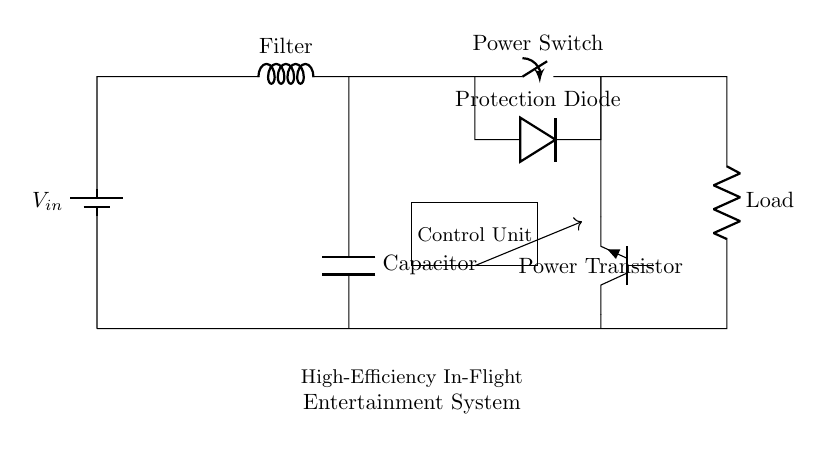What is the power switch labeled as? The label on the power switch component in the circuit diagram is "Power Switch".
Answer: Power Switch What kind of load is shown in this circuit? The component labeled as "Load" represents the part of the circuit that consumes power, typically categorized as a resistive load in high-power appliances.
Answer: Load What type of capacitor is represented in the circuit? The component labeled simply as "Capacitor" indicates a standard filtering capacitor, which is used to smooth voltage fluctuations in the circuit.
Answer: Capacitor How many main components are directly connected in series in this circuit? The components in series are the battery, filter, power switch, and load, totaling four main components directly connected.
Answer: Four What is the function of the protection diode? The protection diode's role is to prevent reverse current flow, which safeguards the circuit from potential damage due to reversed polarity.
Answer: Prevent reverse current What is the purpose of the control unit in this design? The control unit is responsible for managing the overall operation, including switching the power on and off and possibly regulating the system's efficiency.
Answer: Manage operation What type of transistor is used in the circuit? The diagram indicates the use of a "Tnpn" type transistor, which is a specific configuration of a bipolar junction transistor often used for switching or amplification.
Answer: Npn 